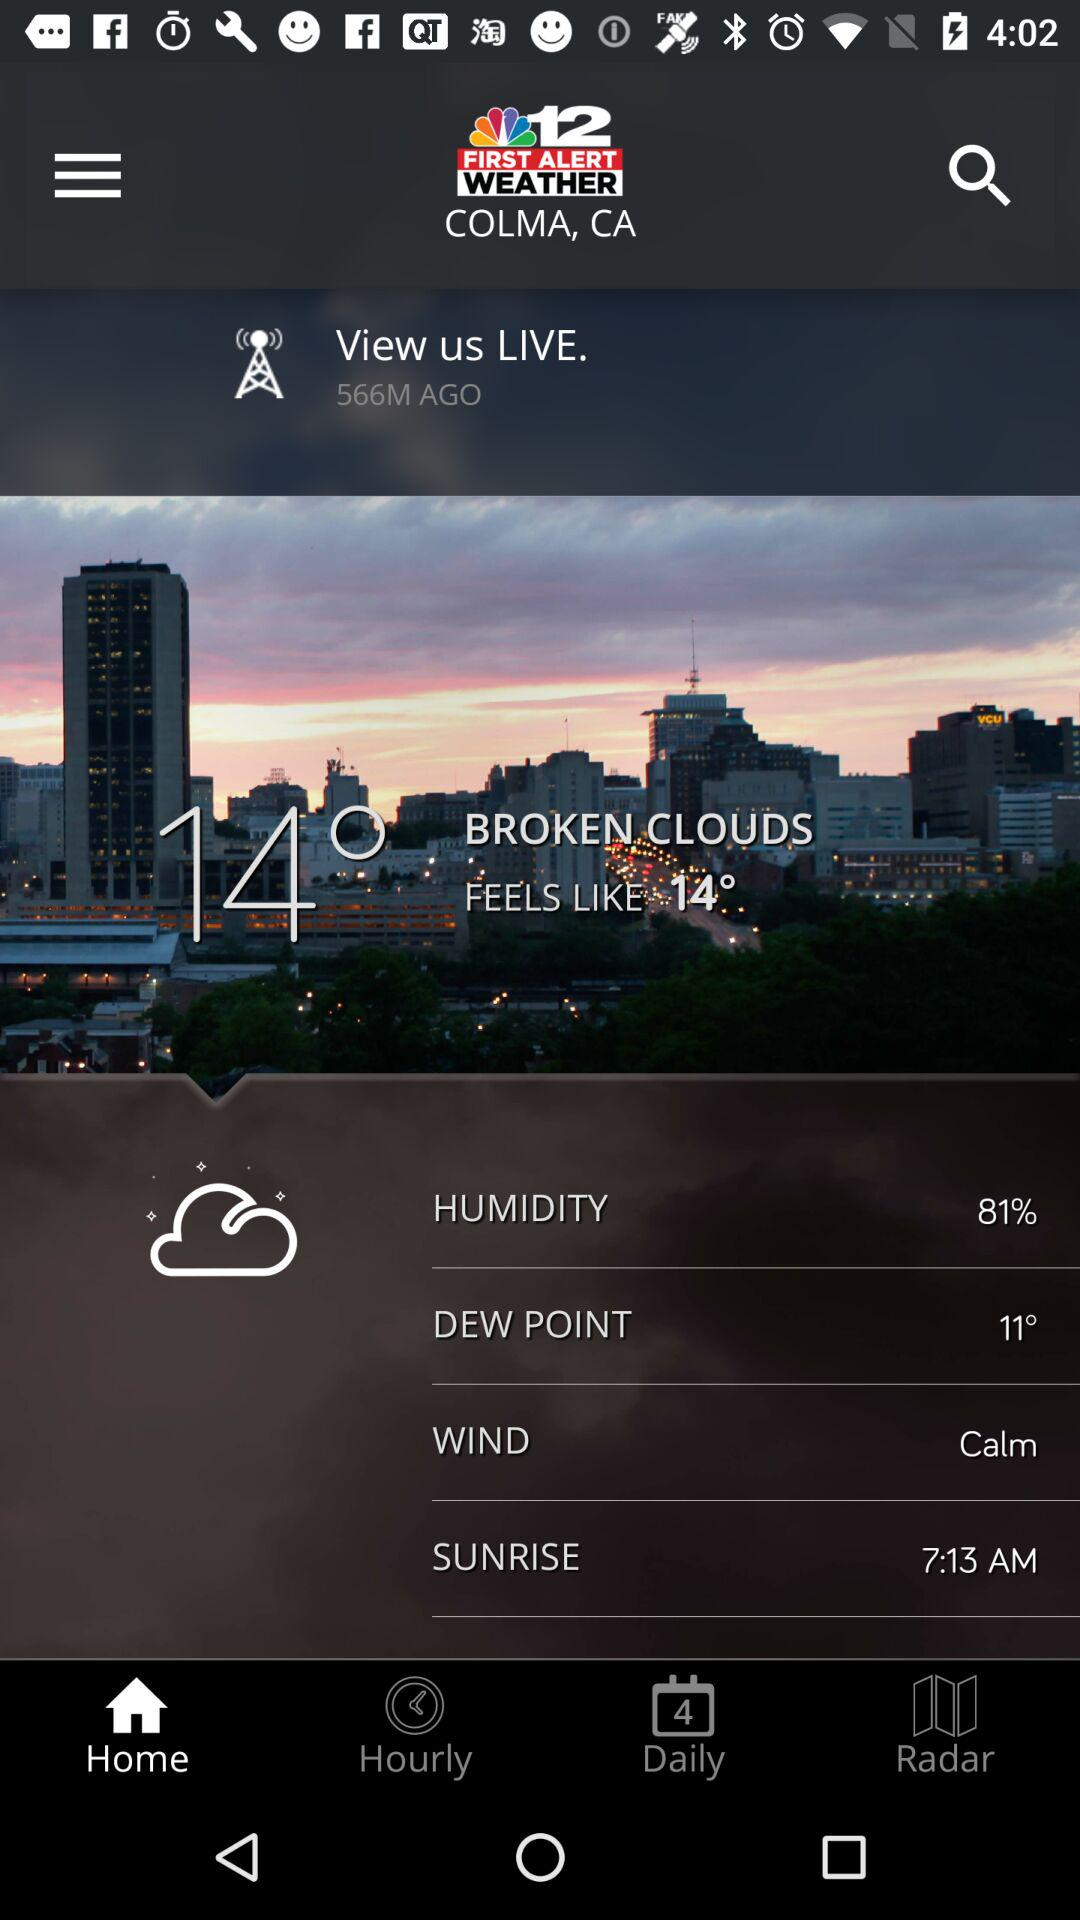What is the difference in degrees between the current temperature and the dew point?
Answer the question using a single word or phrase. 3° 